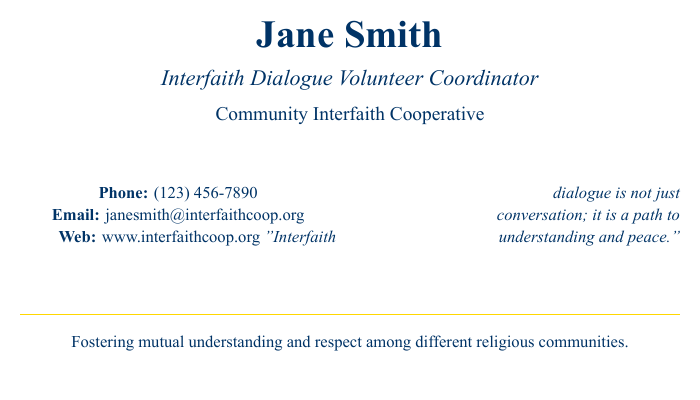What is the name of the Interfaith Dialogue Volunteer Coordinator? The document states the name of the coordinator as "Jane Smith."
Answer: Jane Smith What is the phone number provided on the business card? The document lists the phone number as "(123) 456-7890."
Answer: (123) 456-7890 What organization is associated with Jane Smith? The business card mentions the organization as "Community Interfaith Cooperative."
Answer: Community Interfaith Cooperative What is the email address listed on the card? The email address on the card is "janesmith@interfaithcoop.org."
Answer: janesmith@interfaithcoop.org What is the main goal of the coordinator as stated in the document? The document mentions the goal as "Fostering mutual understanding and respect among different religious communities."
Answer: Fostering mutual understanding and respect among different religious communities What type of dialogue is mentioned in the quote on the card? The quote emphasizes that "Interfaith dialogue is not just conversation."
Answer: conversation How is the visual style of the document described? The document utilizes a color scheme with a main color of dark blue and an accent color of gold.
Answer: dark blue and gold What is the web address provided for more information? The business card lists the web address as "www.interfaithcoop.org."
Answer: www.interfaithcoop.org What is the general theme of the quote on the business card? The quote conveys a theme of understanding and peace through interfaith dialogue.
Answer: understanding and peace 